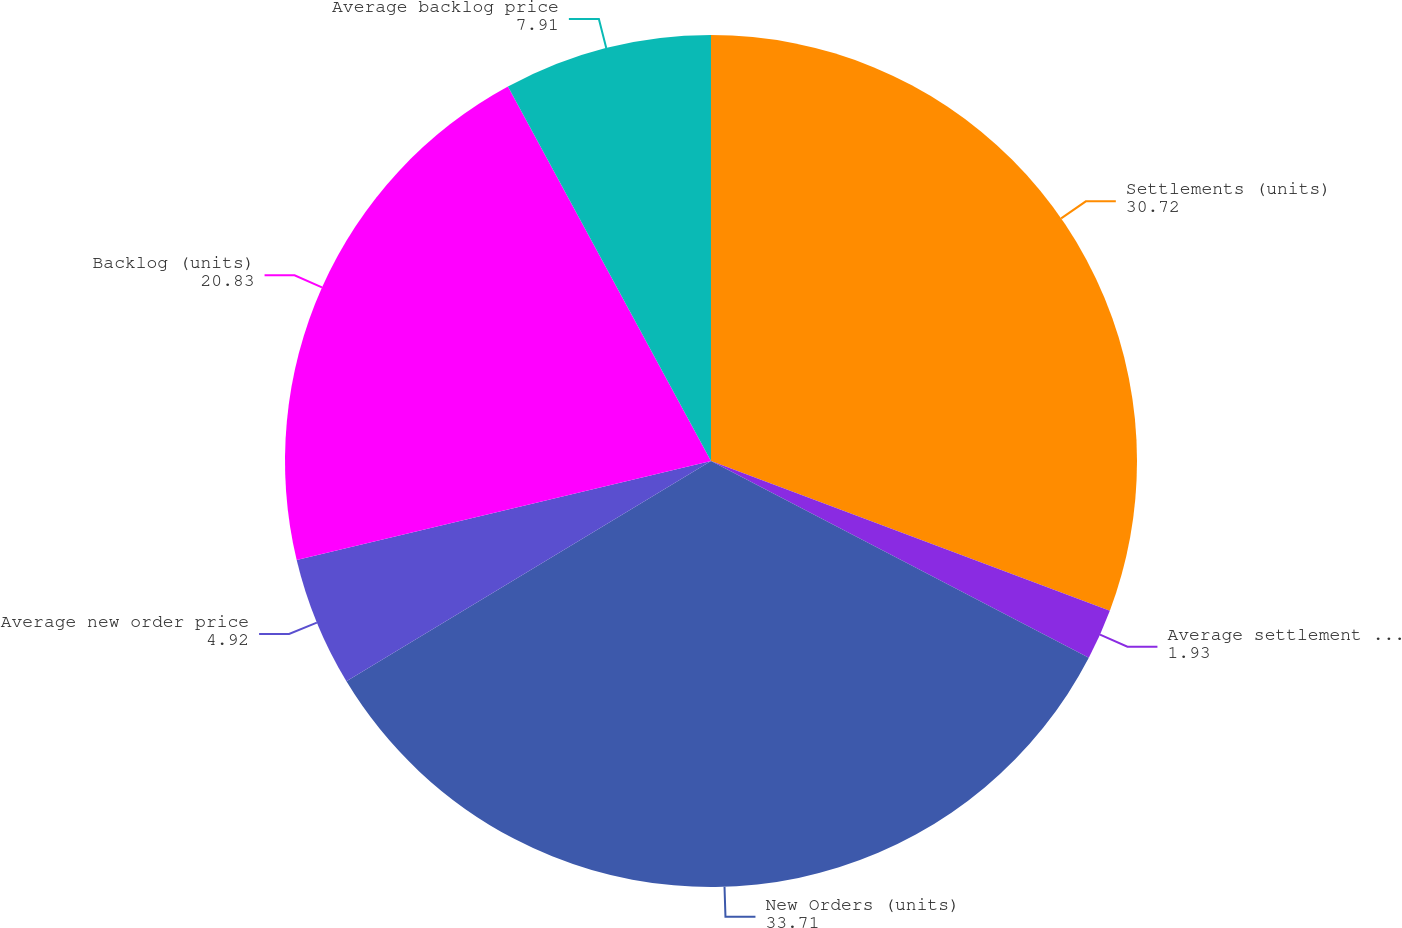<chart> <loc_0><loc_0><loc_500><loc_500><pie_chart><fcel>Settlements (units)<fcel>Average settlement price<fcel>New Orders (units)<fcel>Average new order price<fcel>Backlog (units)<fcel>Average backlog price<nl><fcel>30.72%<fcel>1.93%<fcel>33.71%<fcel>4.92%<fcel>20.83%<fcel>7.91%<nl></chart> 